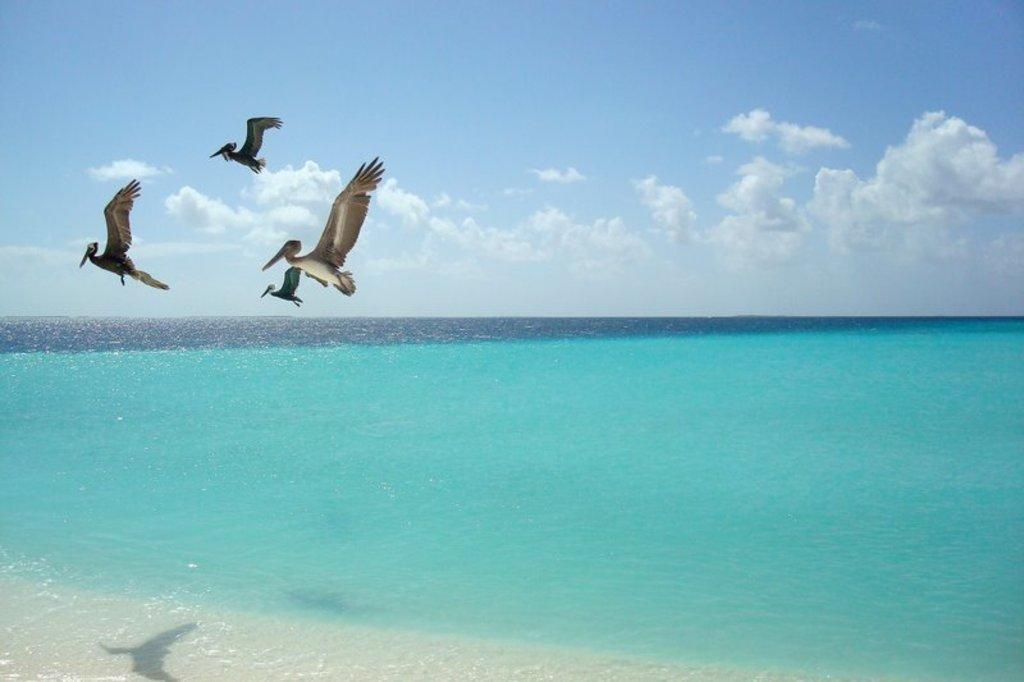What is the primary element in the image? There is water in the image. What type of animals can be seen in the image? Birds can be seen in the image. What part of the natural environment is visible in the image? The sky is visible in the image. What can be observed in the sky? Clouds are present in the sky. What type of furniture can be seen in the image? There is no furniture present in the image; it features water, birds, and clouds in the sky. 